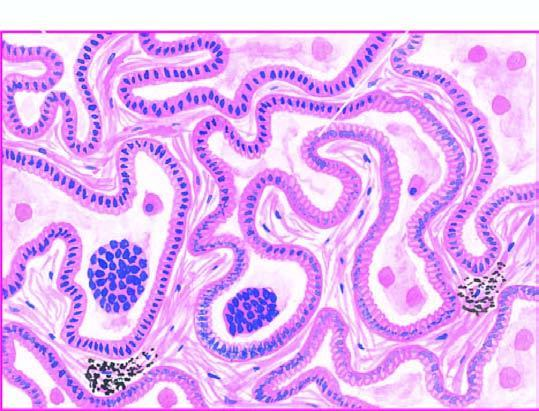re 3 components: ghon 's focus, lined by cuboidal to tall columnar and mucin-secreting tumour cells with papillary growth pattern?
Answer the question using a single word or phrase. No 